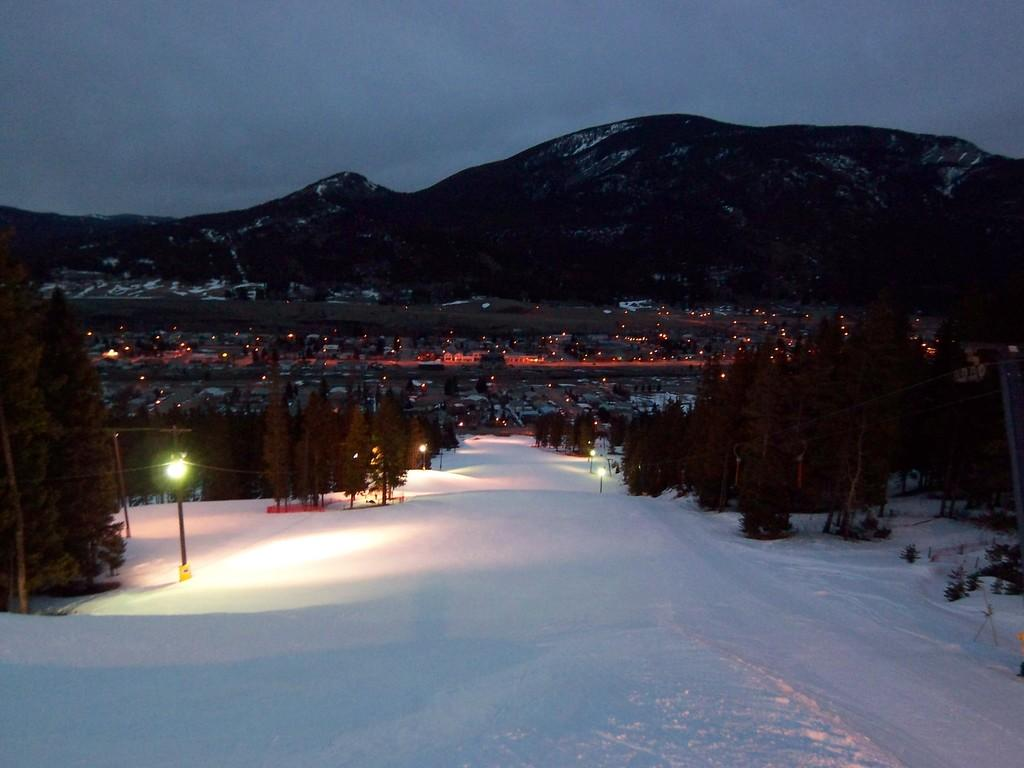What is the primary feature at the bottom of the image? There is snow at the bottom of the image. What can be seen on the left side of the image? There are trees on the left side of the image. What is illuminating the scene in the image? There are lights visible in the image. What type of landscape feature is visible in the background of the image? There are hills visible in the background of the image. What type of caption is written on the snow in the image? There is no caption written on the snow in the image. What invention is being demonstrated in the image? There is no invention being demonstrated in the image. 